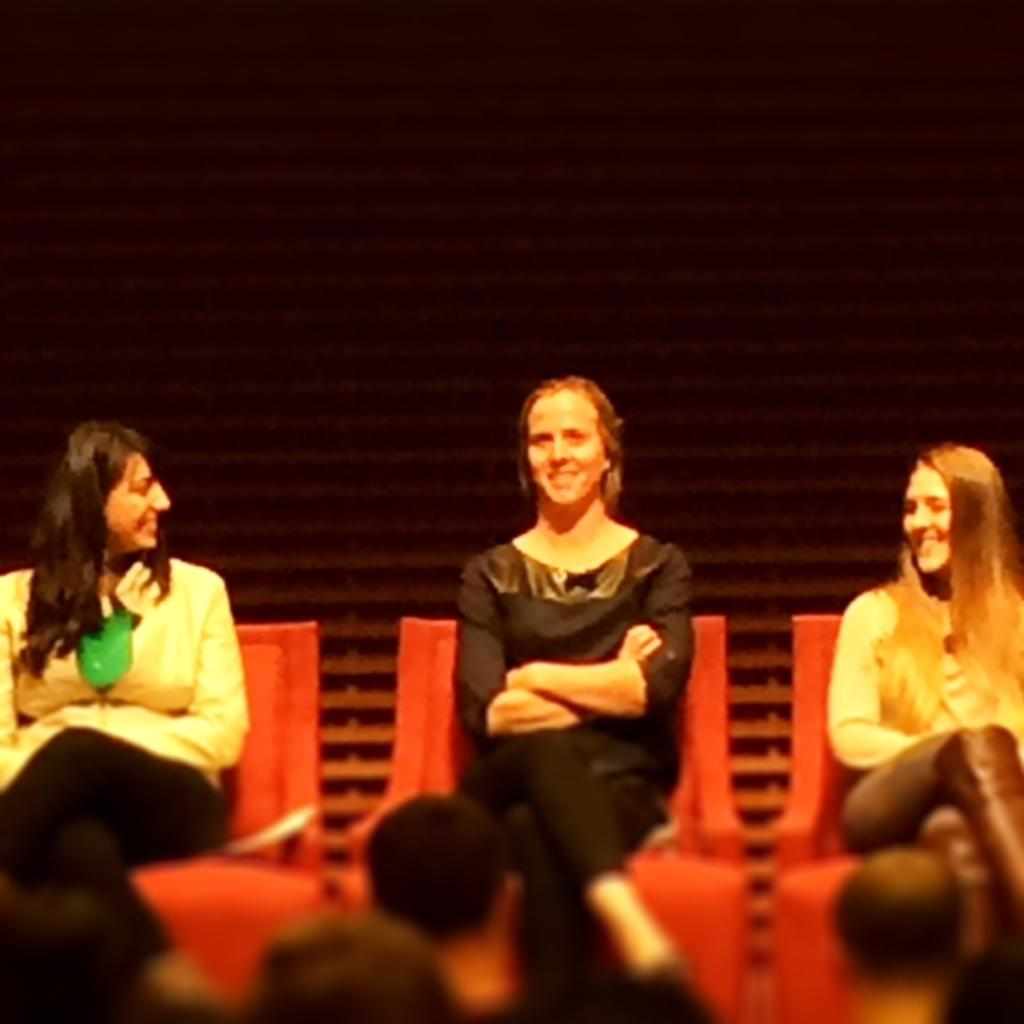What is the main subject of the image? The main subject of the image is a group of people. What are the people in the image doing? The people are sitting on chairs. Where are the people located in the image? The group of people is in the foreground of the image. What is the girl's interest in the moon in the image? There is no girl or mention of the moon in the image; it only features a group of people sitting on chairs. 